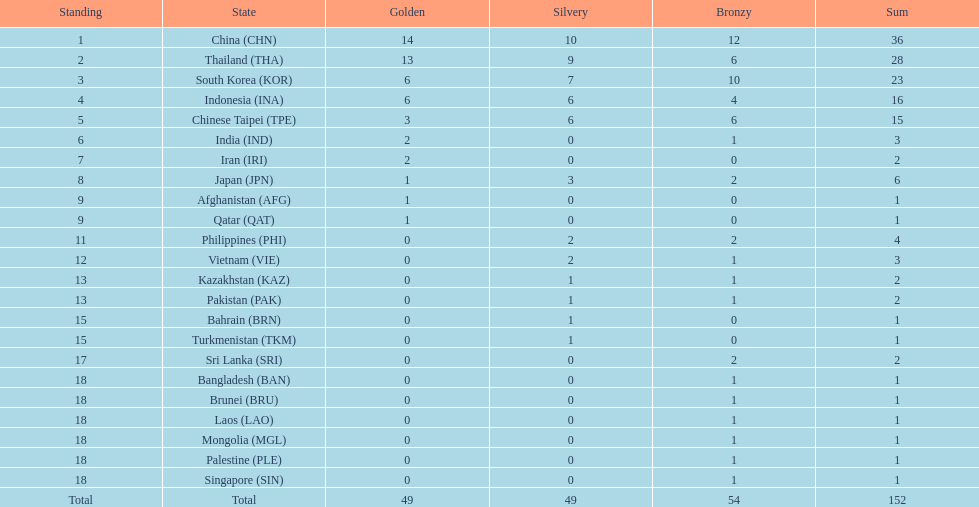Which nation ranked first for the total number of medals won? China (CHN). 